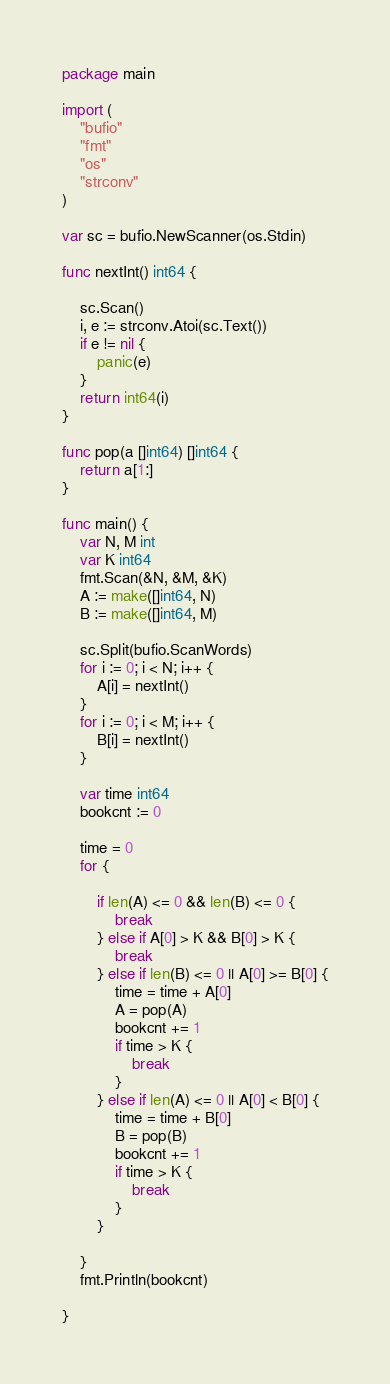<code> <loc_0><loc_0><loc_500><loc_500><_Go_>package main

import (
	"bufio"
	"fmt"
	"os"
	"strconv"
)

var sc = bufio.NewScanner(os.Stdin)

func nextInt() int64 {

	sc.Scan()
	i, e := strconv.Atoi(sc.Text())
	if e != nil {
		panic(e)
	}
	return int64(i)
}

func pop(a []int64) []int64 {
	return a[1:]
}

func main() {
	var N, M int
	var K int64
	fmt.Scan(&N, &M, &K)
	A := make([]int64, N)
	B := make([]int64, M)

	sc.Split(bufio.ScanWords)
	for i := 0; i < N; i++ {
		A[i] = nextInt()
	}
	for i := 0; i < M; i++ {
		B[i] = nextInt()
	}

	var time int64
	bookcnt := 0

	time = 0
	for {

		if len(A) <= 0 && len(B) <= 0 {
			break
		} else if A[0] > K && B[0] > K {
			break
		} else if len(B) <= 0 || A[0] >= B[0] {
			time = time + A[0]
			A = pop(A)
			bookcnt += 1
			if time > K {
				break
			}
		} else if len(A) <= 0 || A[0] < B[0] {
			time = time + B[0]
			B = pop(B)
			bookcnt += 1
			if time > K {
				break
			}
		}

	}
	fmt.Println(bookcnt)

}
</code> 